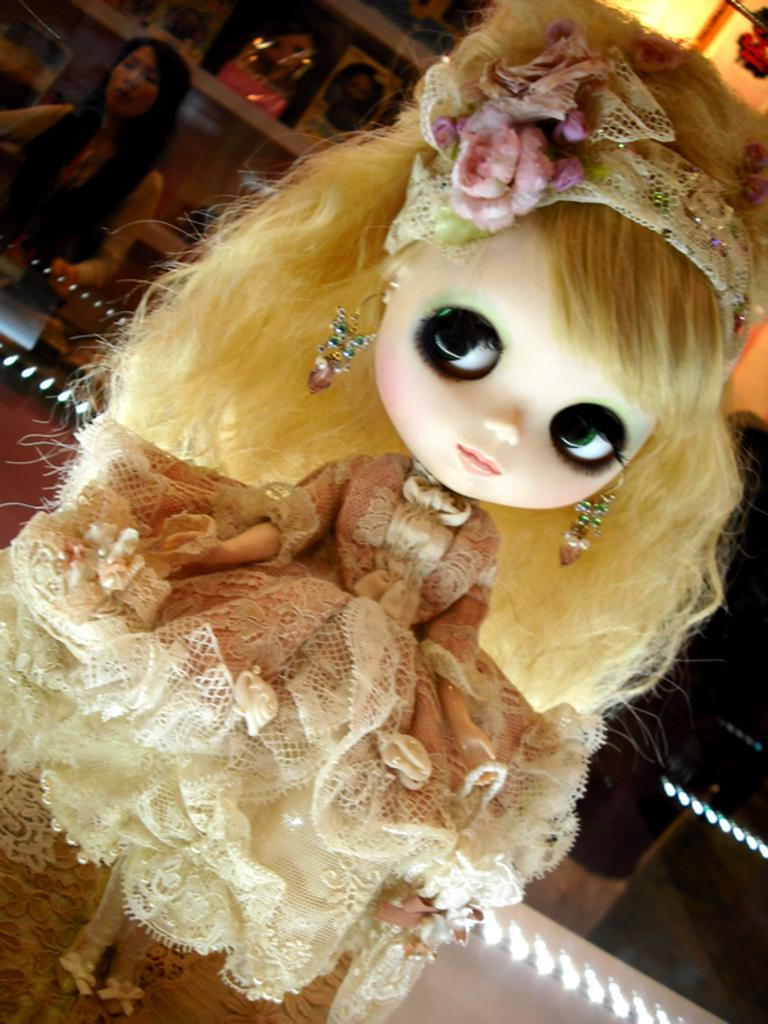What is the main subject in the image? There is a doll in the image. Can you describe the woman's position in relation to the doll? There is a woman behind the doll in the image. What else can be seen in the image besides the doll and the woman? There are objects and lights in the image. What type of meal is the maid preparing in the image? There is no maid or meal present in the image. What is the doll's temper like in the image? The image does not depict the doll's temper; it only shows the doll and its surroundings. 